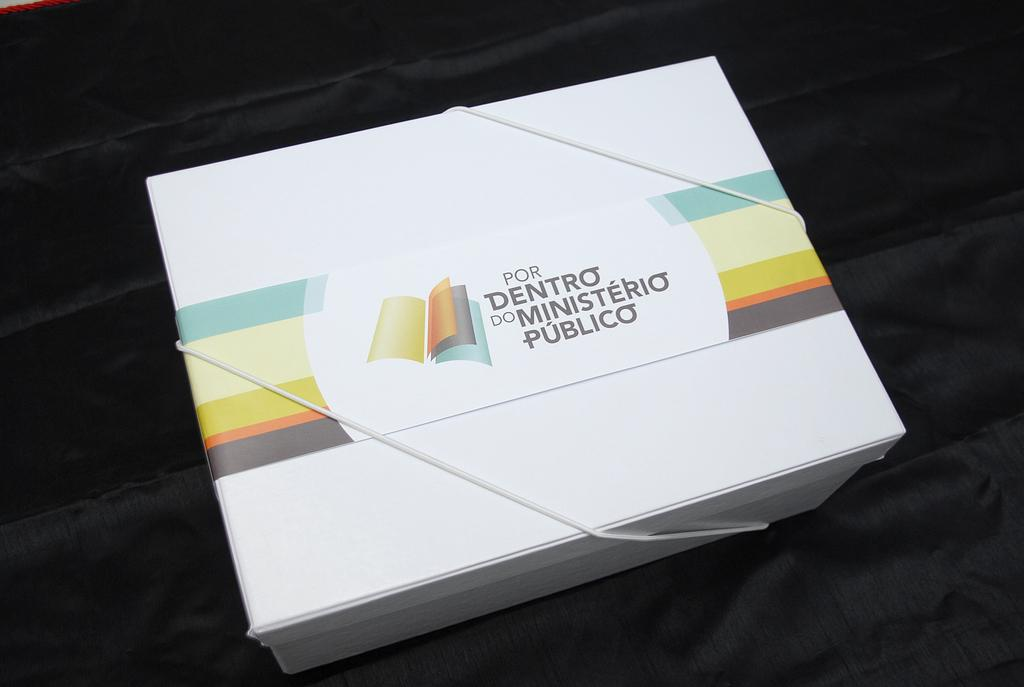<image>
Describe the image concisely. Package of Design that says POR DENTRO DO MINISTERIO PUBLICO. 